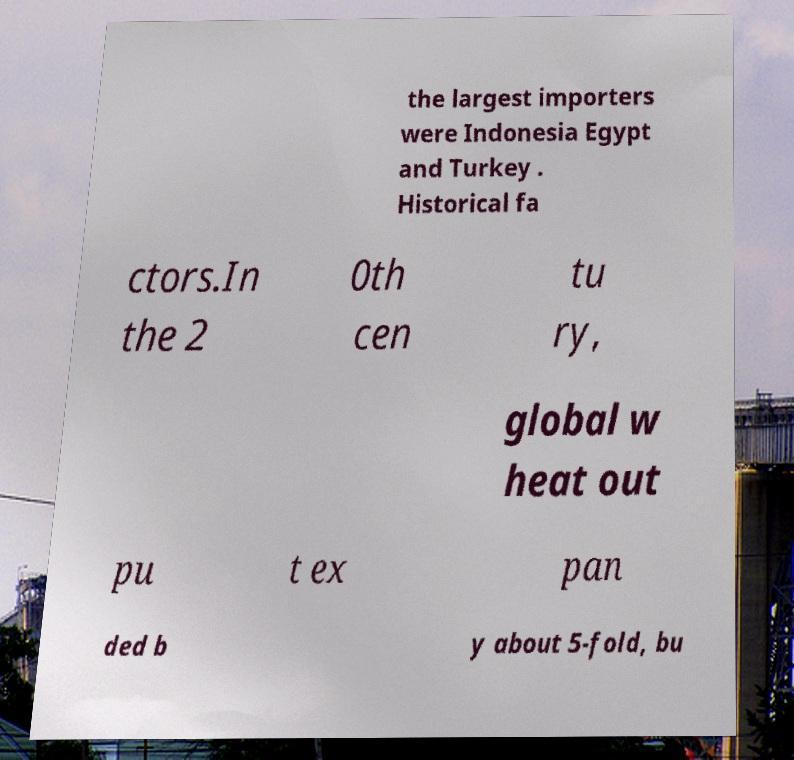Could you extract and type out the text from this image? the largest importers were Indonesia Egypt and Turkey . Historical fa ctors.In the 2 0th cen tu ry, global w heat out pu t ex pan ded b y about 5-fold, bu 